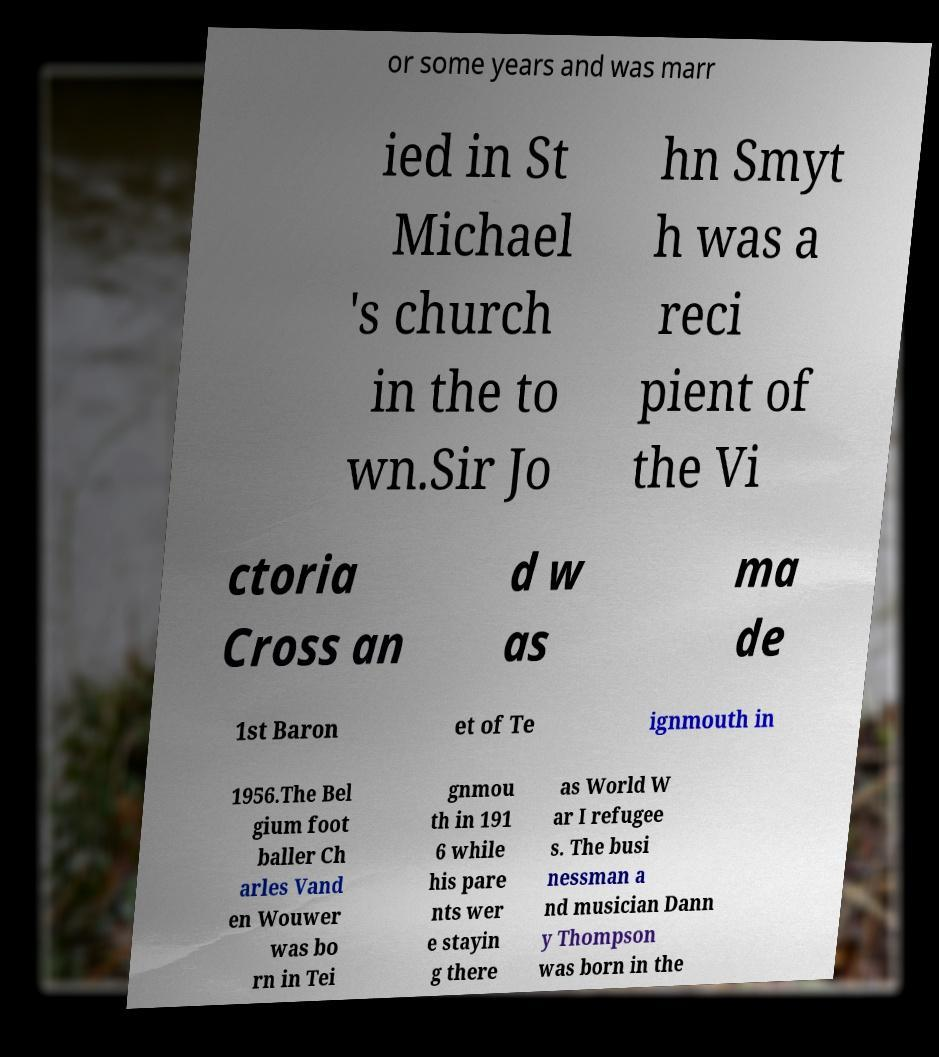Could you extract and type out the text from this image? or some years and was marr ied in St Michael 's church in the to wn.Sir Jo hn Smyt h was a reci pient of the Vi ctoria Cross an d w as ma de 1st Baron et of Te ignmouth in 1956.The Bel gium foot baller Ch arles Vand en Wouwer was bo rn in Tei gnmou th in 191 6 while his pare nts wer e stayin g there as World W ar I refugee s. The busi nessman a nd musician Dann y Thompson was born in the 